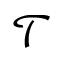Convert formula to latex. <formula><loc_0><loc_0><loc_500><loc_500>\mathcal { T }</formula> 